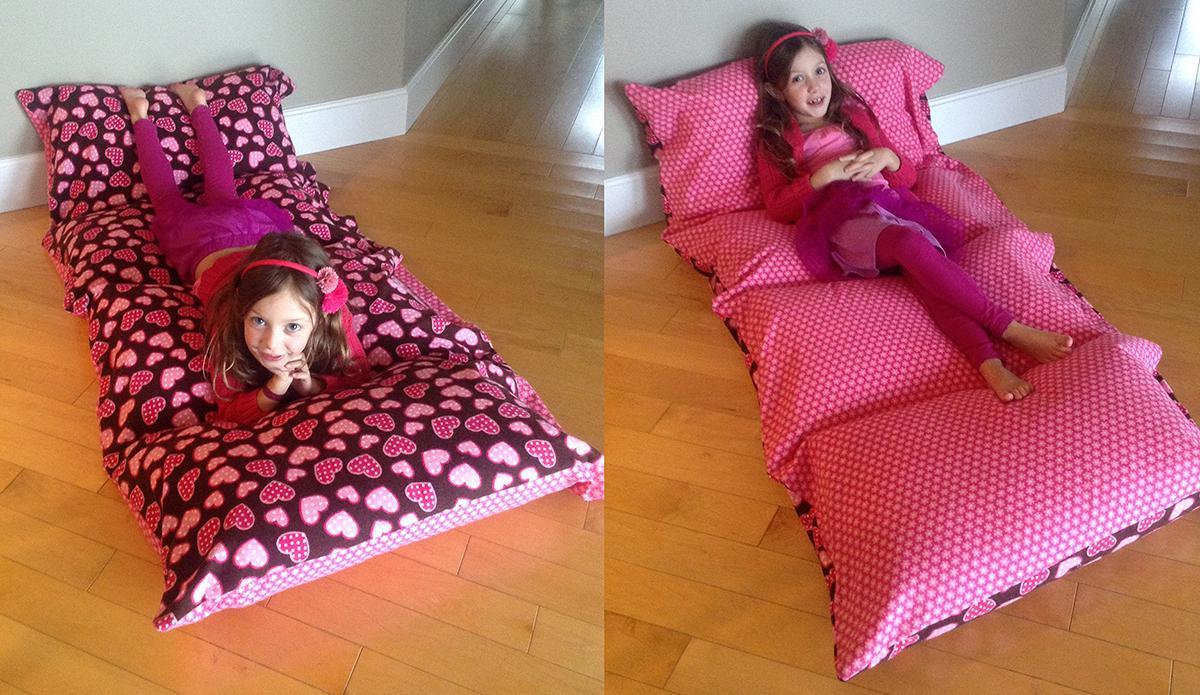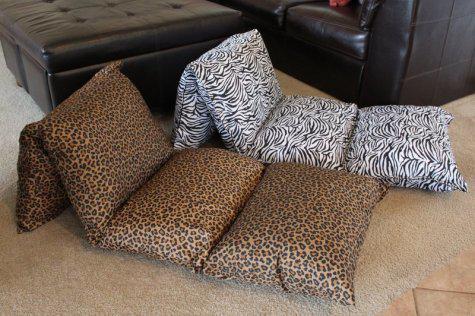The first image is the image on the left, the second image is the image on the right. Assess this claim about the two images: "there are two children laying on mats on a wood floor". Correct or not? Answer yes or no. Yes. 